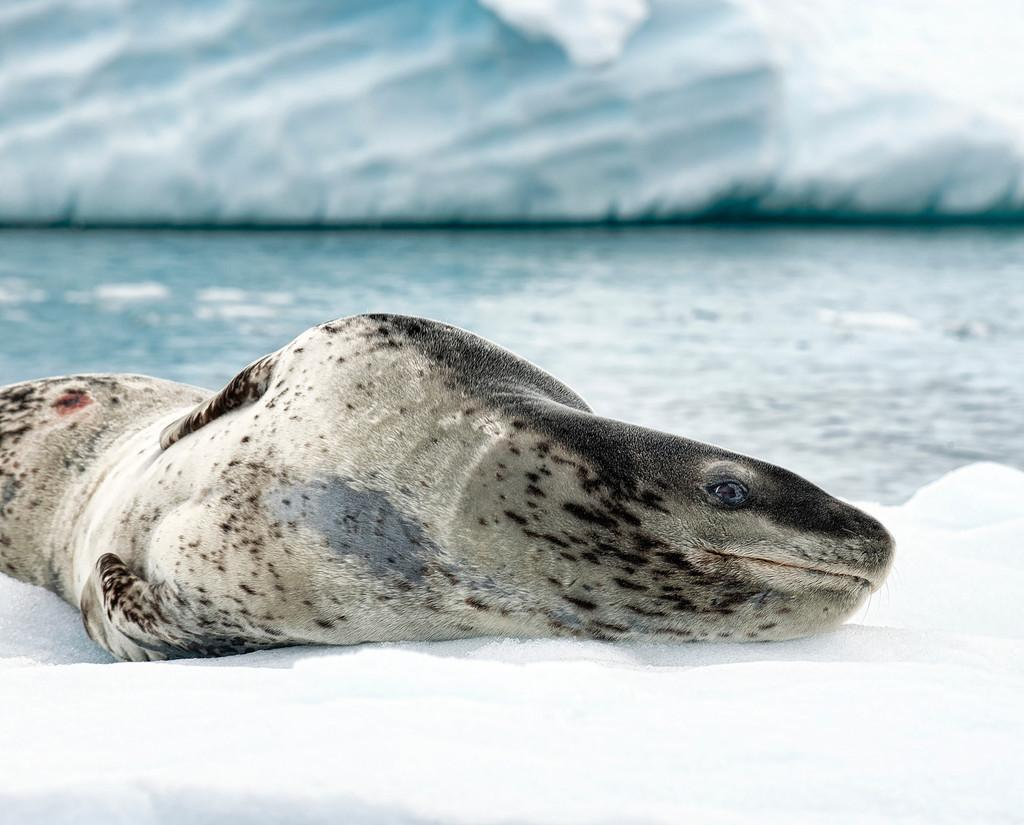What animal can be seen in the foreground of the picture? There is a seal on the ice in the foreground of the picture. How would you describe the background of the image? The background of the image is blurred. What natural element is visible in the background of the image? There is water visible in the background of the image. What other large ice formation can be seen in the background of the image? There is an iceberg in the background of the image. Can you see a hose spraying water near the seal in the image? There is no hose visible in the image; it only features a seal on the ice, a blurred background, water, and an iceberg. 